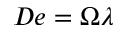<formula> <loc_0><loc_0><loc_500><loc_500>D e = \Omega \lambda</formula> 